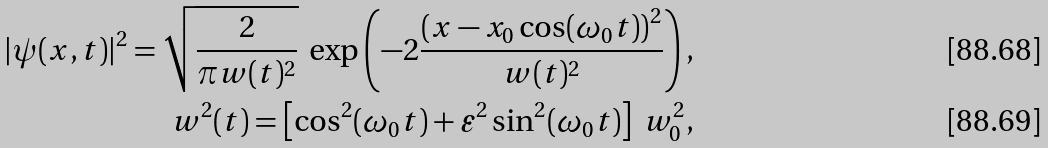<formula> <loc_0><loc_0><loc_500><loc_500>| \psi ( x , t ) | ^ { 2 } = \sqrt { \frac { 2 } { \pi w ( t ) ^ { 2 } } } \ \exp \left ( - 2 \frac { \left ( x - x _ { 0 } \cos ( \omega _ { 0 } t ) \right ) ^ { 2 } } { w ( t ) ^ { 2 } } \right ) , \\ w ^ { 2 } ( t ) = \left [ \cos ^ { 2 } ( \omega _ { 0 } t ) + \varepsilon ^ { 2 } \sin ^ { 2 } ( \omega _ { 0 } t ) \right ] \ w _ { 0 } ^ { 2 } ,</formula> 